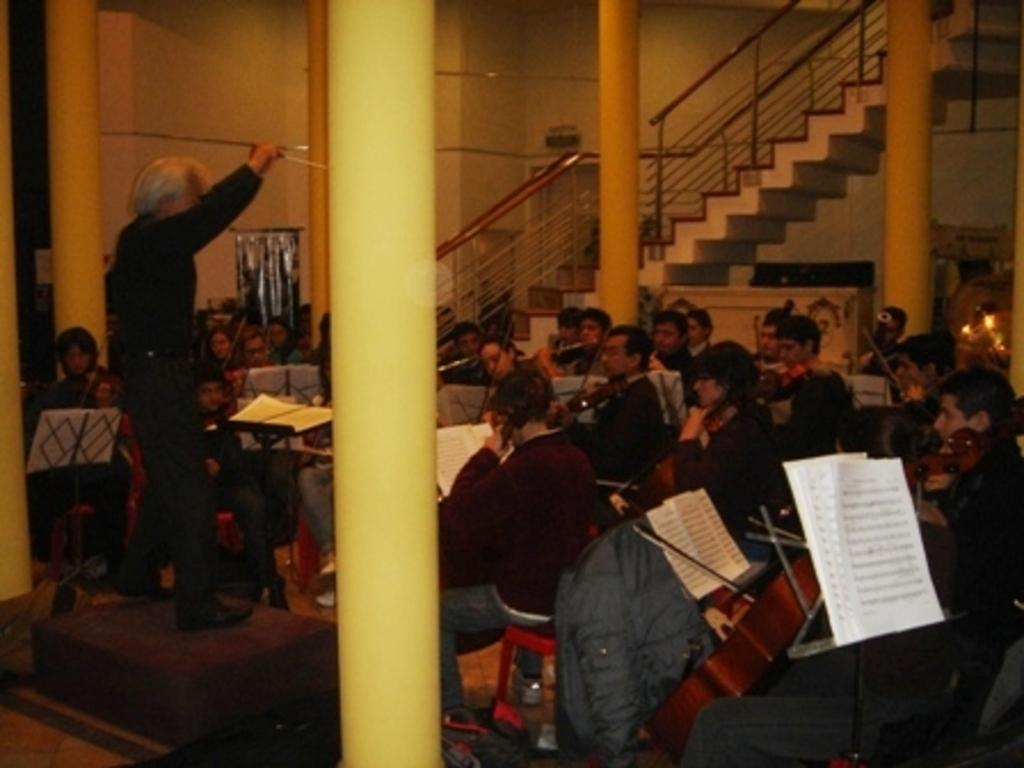What type of architectural feature can be seen in the image? There are pillars in the image. What can be used for ascending or descending in the image? There are stairs in the image. What type of furniture is present in the image? There are chairs in the image. Who or what is present in the image? There are persons in the image. What type of item can be used for reading or learning? There are books in the image. What is visible in the background of the image? There is a wall in the background of the image. What type of tooth is visible in the image? There is no tooth present in the image. What is the base of the image made of? The image is a digital representation and does not have a physical base. What type of noise can be heard in the image? The image is a still picture and does not have any sound or noise. 